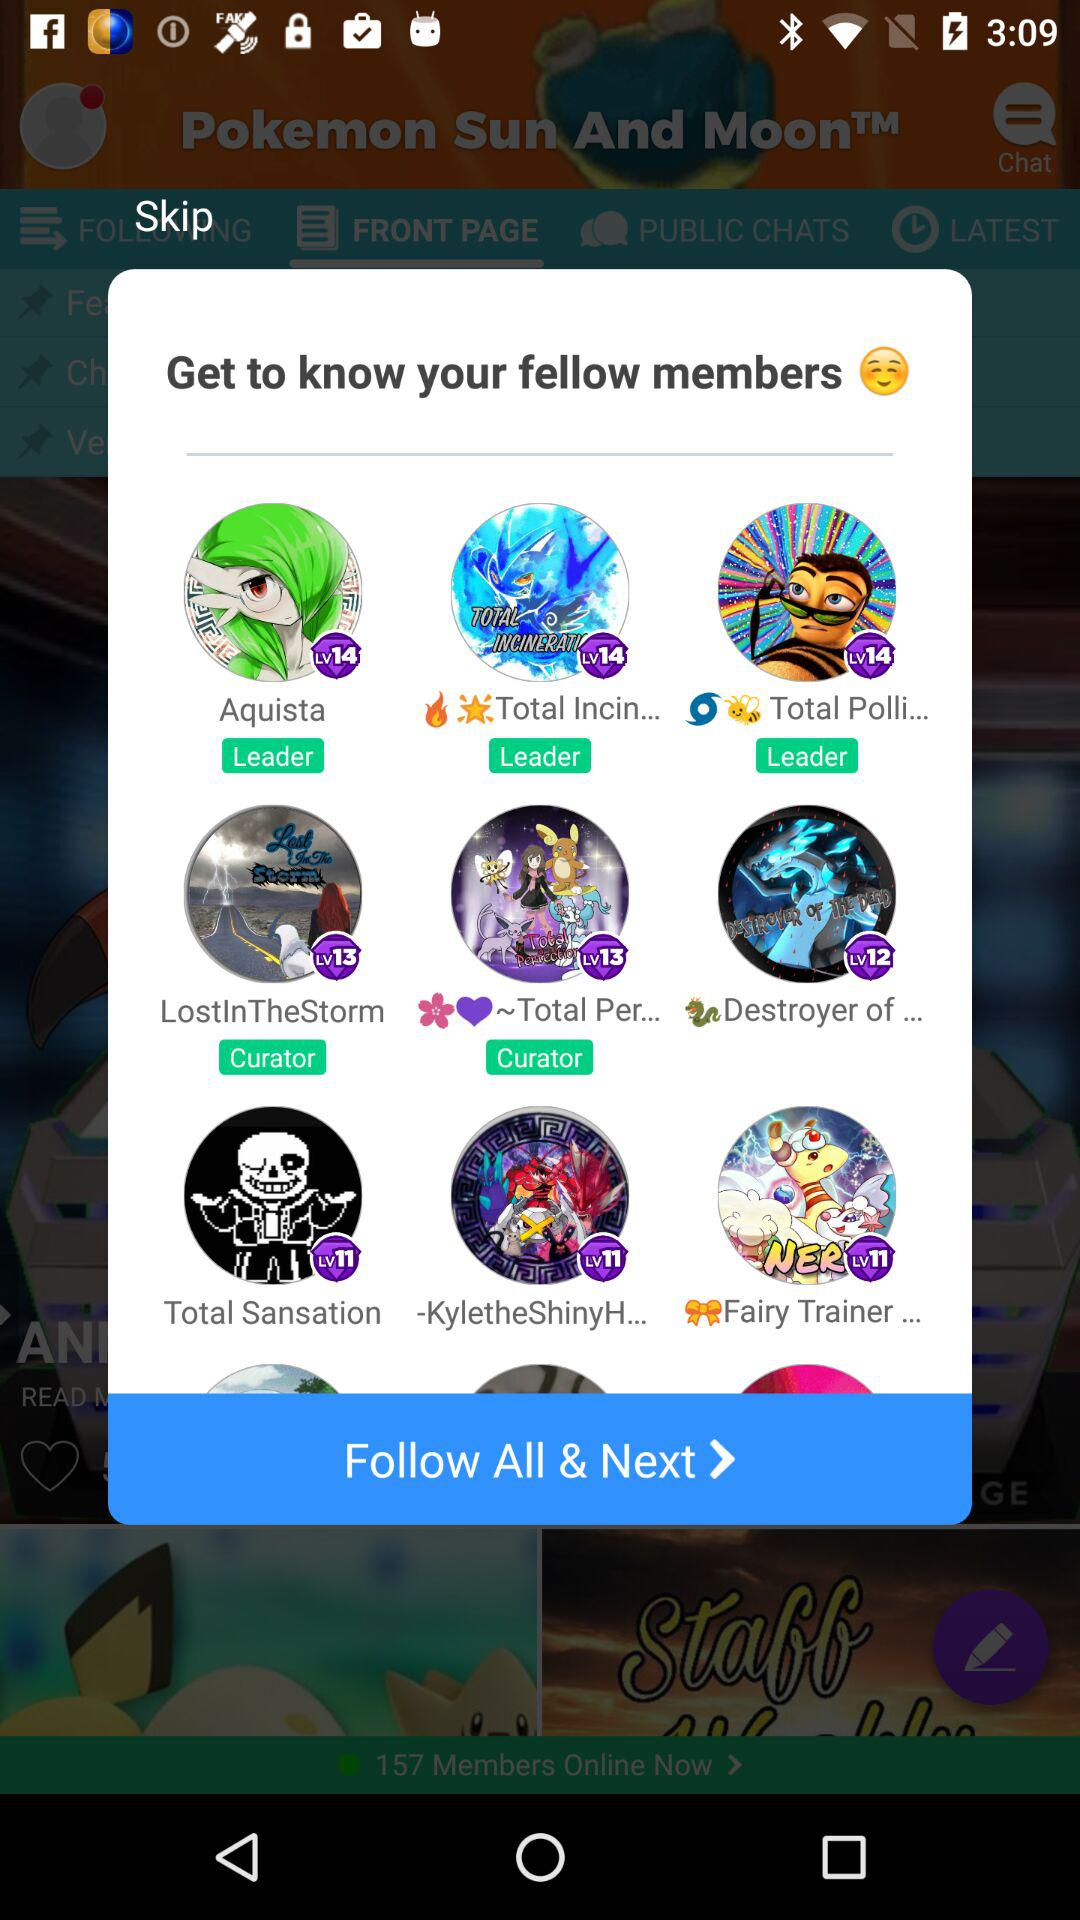How many leaders are there in total?
Answer the question using a single word or phrase. 3 